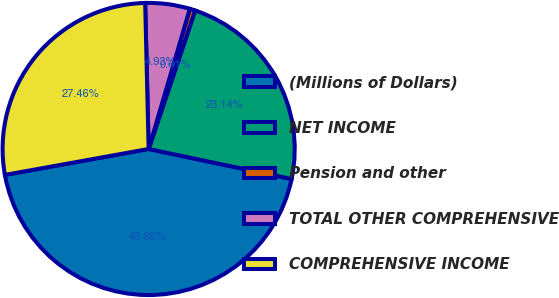<chart> <loc_0><loc_0><loc_500><loc_500><pie_chart><fcel>(Millions of Dollars)<fcel>NET INCOME<fcel>Pension and other<fcel>TOTAL OTHER COMPREHENSIVE<fcel>COMPREHENSIVE INCOME<nl><fcel>43.86%<fcel>23.14%<fcel>0.61%<fcel>4.93%<fcel>27.46%<nl></chart> 